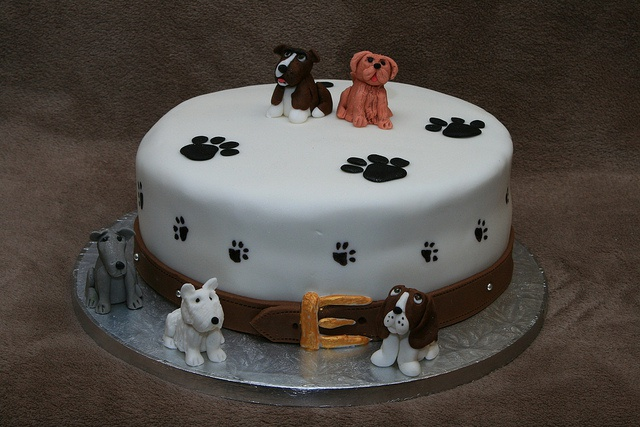Describe the objects in this image and their specific colors. I can see cake in black, darkgray, gray, and lightgray tones, dog in black, gray, and darkgray tones, dog in black, darkgray, and gray tones, dog in black and purple tones, and dog in black, darkgray, and gray tones in this image. 